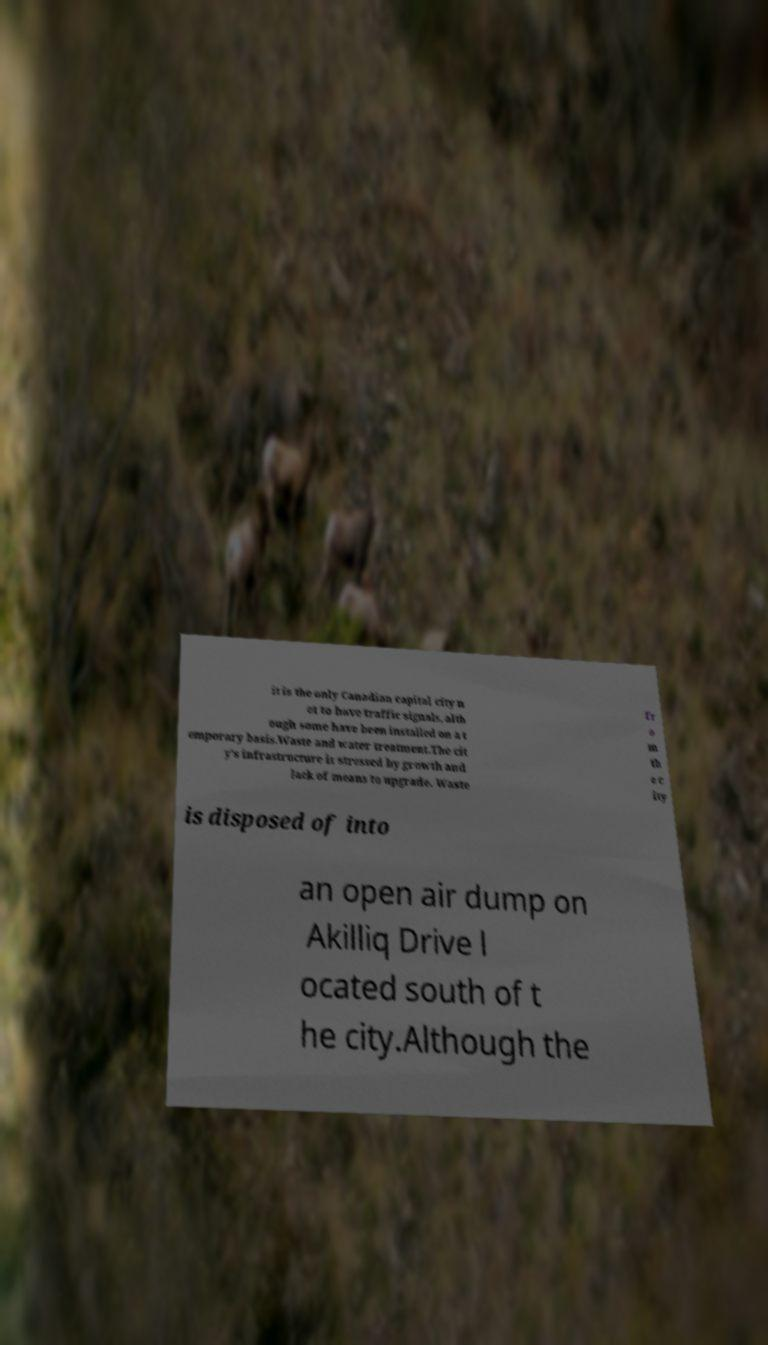Can you read and provide the text displayed in the image?This photo seems to have some interesting text. Can you extract and type it out for me? it is the only Canadian capital city n ot to have traffic signals, alth ough some have been installed on a t emporary basis.Waste and water treatment.The cit y's infrastructure is stressed by growth and lack of means to upgrade. Waste fr o m th e c ity is disposed of into an open air dump on Akilliq Drive l ocated south of t he city.Although the 